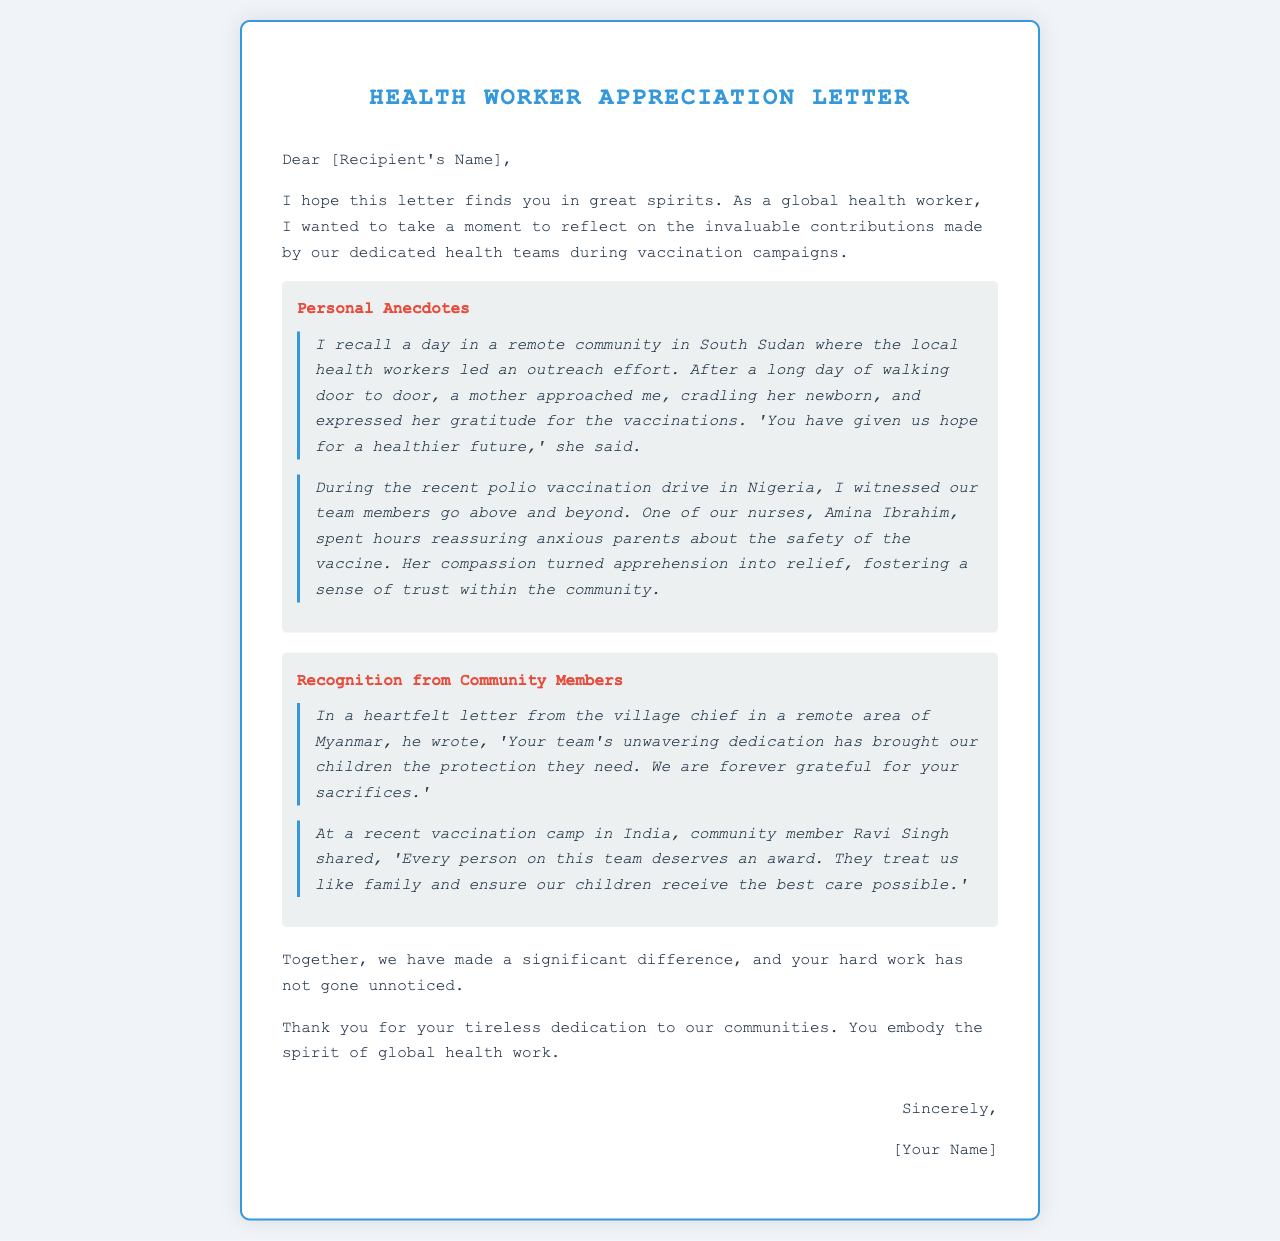what is the title of the letter? The title of the letter is indicated at the top as it is presented in a larger font.
Answer: Health Worker Appreciation Letter who expressed gratitude for vaccinations in South Sudan? The document mentions a specific mother who expressed gratitude after receiving vaccinations for her newborn.
Answer: a mother what is the name of the nurse mentioned in the Nigeria polio vaccination drive? The nurse's name is specifically mentioned in the context of her actions during the polio vaccination drive.
Answer: Amina Ibrahim what did the village chief in Myanmar write about the health team's dedication? The village chief's sentiments reflect appreciation for the health team's efforts in protecting children.
Answer: unwavering dedication where did community member Ravi Singh share his thoughts? Ravi Singh's recognition of the health team was expressed during a specific event related to vaccinations.
Answer: vaccination camp in India how did the mother describe the impact of vaccinations? The mother's words clearly indicate her feelings about the future concerning vaccinations.
Answer: hope for a healthier future what is the overall tone of the letter? The tone can be determined by the language and expressions of appreciation throughout the letter.
Answer: appreciative what is the purpose of this letter? The purpose of the letter is conveyed in its content, focusing on recognition and appreciation for specific contributions.
Answer: appreciation 